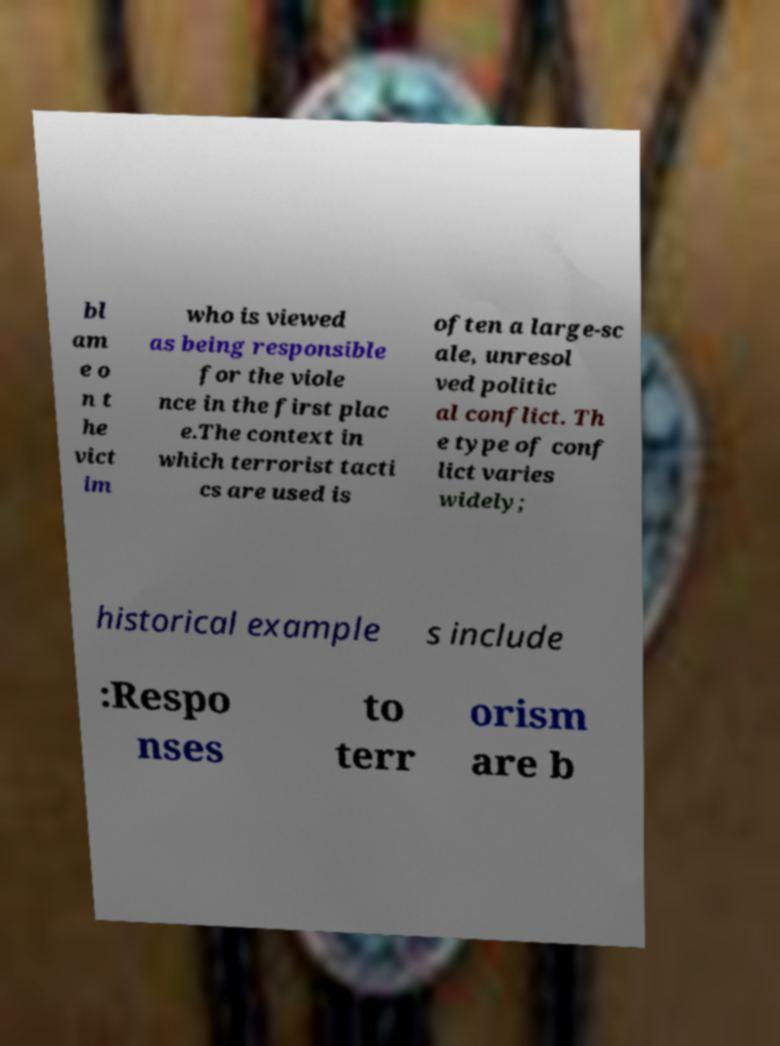What messages or text are displayed in this image? I need them in a readable, typed format. bl am e o n t he vict im who is viewed as being responsible for the viole nce in the first plac e.The context in which terrorist tacti cs are used is often a large-sc ale, unresol ved politic al conflict. Th e type of conf lict varies widely; historical example s include :Respo nses to terr orism are b 